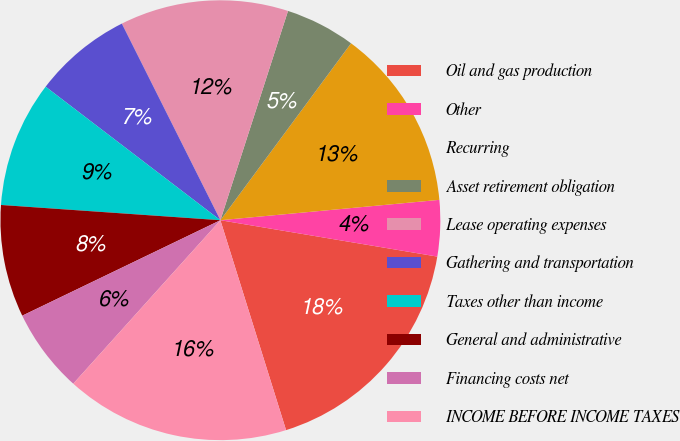Convert chart. <chart><loc_0><loc_0><loc_500><loc_500><pie_chart><fcel>Oil and gas production<fcel>Other<fcel>Recurring<fcel>Asset retirement obligation<fcel>Lease operating expenses<fcel>Gathering and transportation<fcel>Taxes other than income<fcel>General and administrative<fcel>Financing costs net<fcel>INCOME BEFORE INCOME TAXES<nl><fcel>17.53%<fcel>4.12%<fcel>13.4%<fcel>5.15%<fcel>12.37%<fcel>7.22%<fcel>9.28%<fcel>8.25%<fcel>6.19%<fcel>16.49%<nl></chart> 